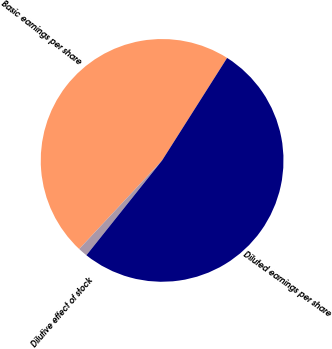Convert chart. <chart><loc_0><loc_0><loc_500><loc_500><pie_chart><fcel>Basic earnings per share<fcel>Dilutive effect of stock<fcel>Diluted earnings per share<nl><fcel>47.02%<fcel>1.25%<fcel>51.72%<nl></chart> 